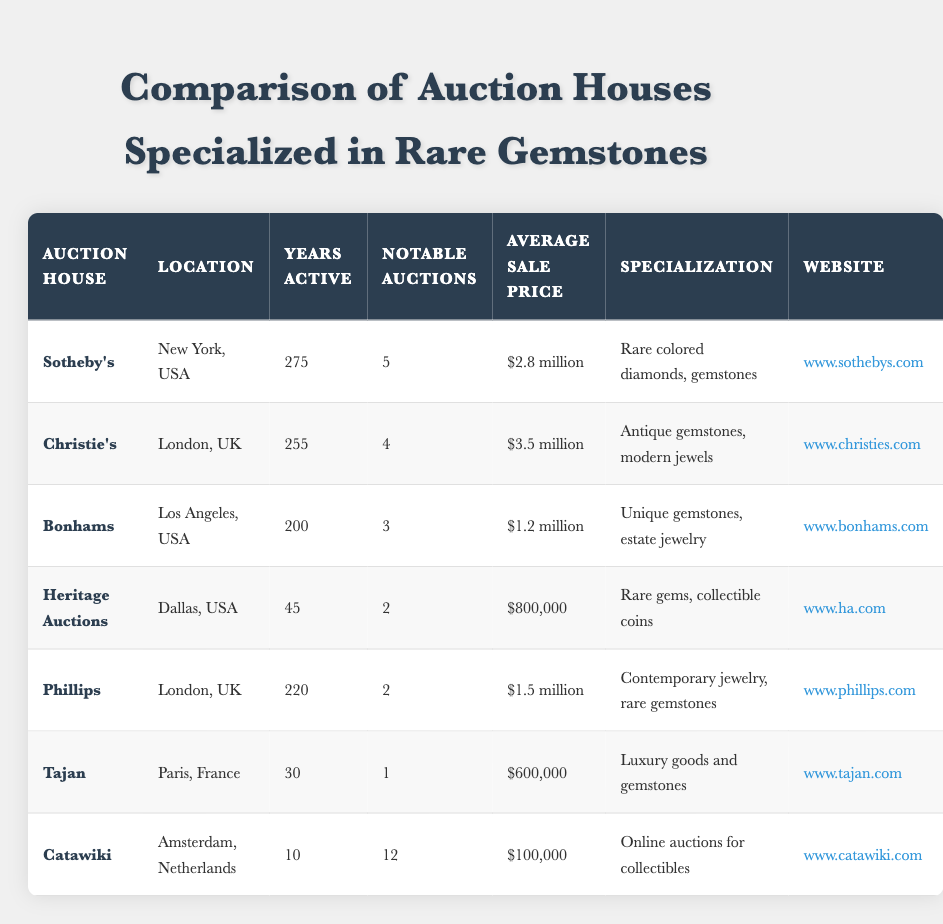What is the location of Sotheby's? The auction house Sotheby's is located in New York, USA, as indicated in the table.
Answer: New York, USA How many years has Christie's been active? The table shows that Christie's has been active for 255 years.
Answer: 255 What is the average sale price for Bonhams? The average sale price for Bonhams, as listed in the table, is $1.2 million.
Answer: $1.2 million Which auction house has the highest average sale price? By comparing the average sale prices in the table, Christie's has the highest average sale price at $3.5 million.
Answer: Christie's How many notable auctions has Heritage Auctions conducted? The table shows that Heritage Auctions has conducted 2 notable auctions.
Answer: 2 Is Tajan specialized in rare gemstones? According to the data, Tajan specializes in luxury goods and gemstones, which does include some rare gemstones, so the answer is yes.
Answer: Yes What is the average sale price deifference between Sotheby's and Phillips? Sotheby's has an average sale price of $2.8 million and Phillips has $1.5 million. The difference is $2.8 million - $1.5 million = $1.3 million.
Answer: $1.3 million Which auction house has the least number of years active? The table indicates that Tajan has been active for the least number of years, which is 30 years.
Answer: Tajan How many notable auctions are combined for Sotheby's and Christie's? Sotheby's has 5 notable auctions and Christie's has 4, so combining these gives 5 + 4 = 9 notable auctions.
Answer: 9 What percentage of notable auctions does Catawiki represent among all auction houses listed? There are a total of 12 notable auctions from Catawiki and 5 + 4 + 3 + 2 + 2 + 1 + 12 = 29 notable auctions in total. The percentage is (12 / 29) * 100 ≈ 41.38%.
Answer: Approximately 41.38% 